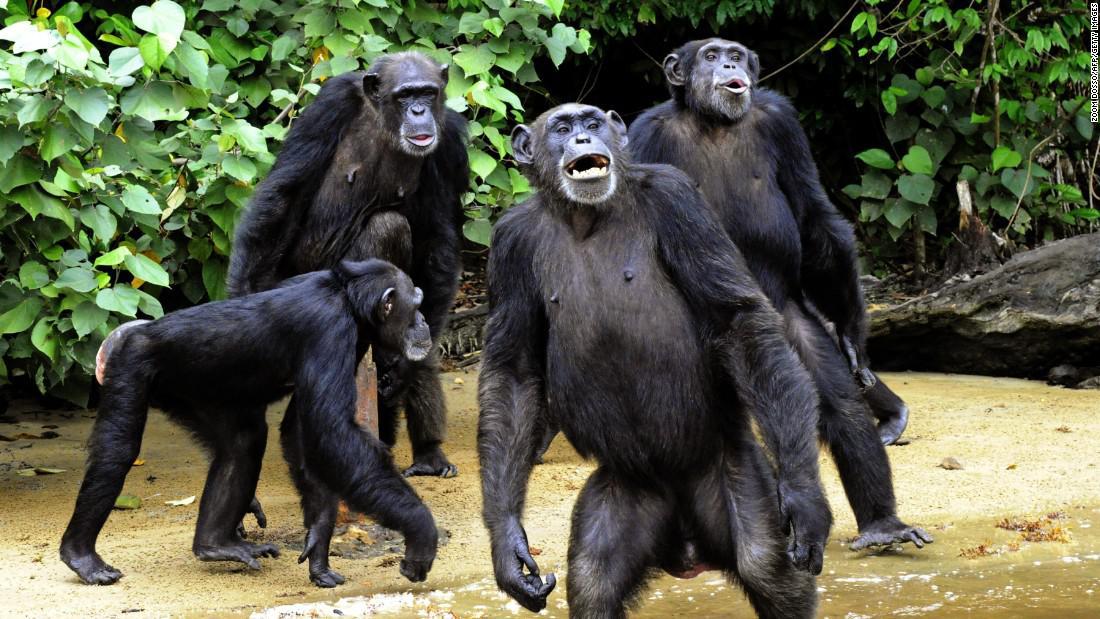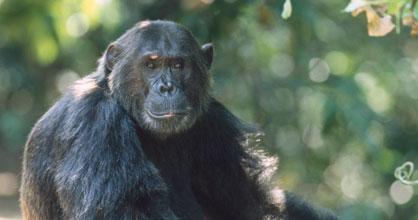The first image is the image on the left, the second image is the image on the right. Assess this claim about the two images: "In one image there is a single chimpanzee and in the other there is a group of at least four.". Correct or not? Answer yes or no. Yes. The first image is the image on the left, the second image is the image on the right. Considering the images on both sides, is "There are a total of 5 monkeys present outside." valid? Answer yes or no. Yes. 